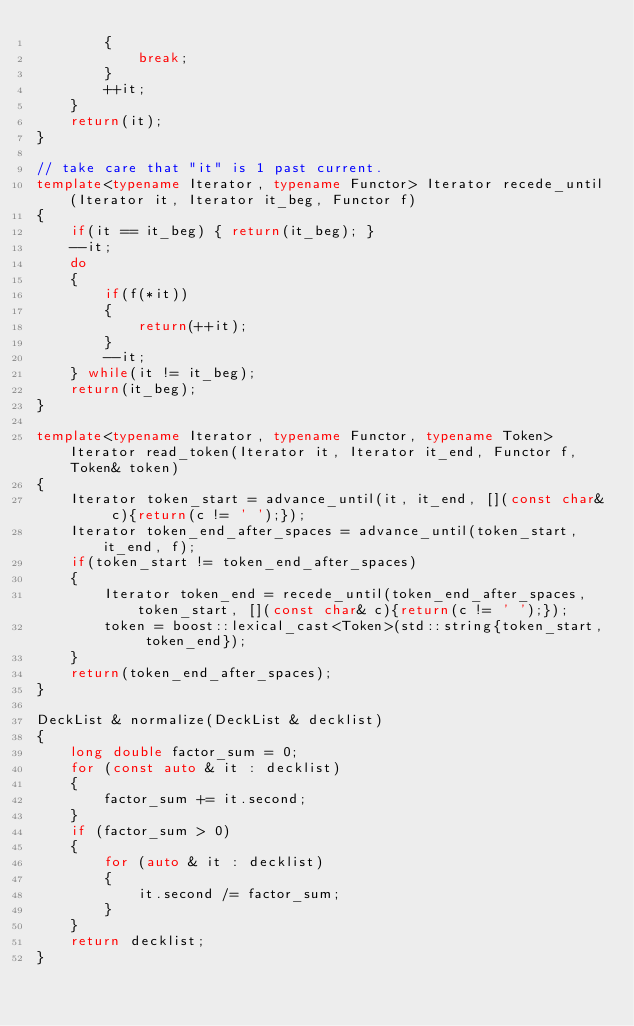<code> <loc_0><loc_0><loc_500><loc_500><_C++_>        {
            break;
        }
        ++it;
    }
    return(it);
}

// take care that "it" is 1 past current.
template<typename Iterator, typename Functor> Iterator recede_until(Iterator it, Iterator it_beg, Functor f)
{
    if(it == it_beg) { return(it_beg); }
    --it;
    do
    {
        if(f(*it))
        {
            return(++it);
        }
        --it;
    } while(it != it_beg);
    return(it_beg);
}

template<typename Iterator, typename Functor, typename Token> Iterator read_token(Iterator it, Iterator it_end, Functor f, Token& token)
{
    Iterator token_start = advance_until(it, it_end, [](const char& c){return(c != ' ');});
    Iterator token_end_after_spaces = advance_until(token_start, it_end, f);
    if(token_start != token_end_after_spaces)
    {
        Iterator token_end = recede_until(token_end_after_spaces, token_start, [](const char& c){return(c != ' ');});
        token = boost::lexical_cast<Token>(std::string{token_start, token_end});
    }
    return(token_end_after_spaces);
}

DeckList & normalize(DeckList & decklist)
{
    long double factor_sum = 0;
    for (const auto & it : decklist)
    {
        factor_sum += it.second;
    }
    if (factor_sum > 0)
    {
        for (auto & it : decklist)
        {
            it.second /= factor_sum;
        }
    }
    return decklist;
}
</code> 